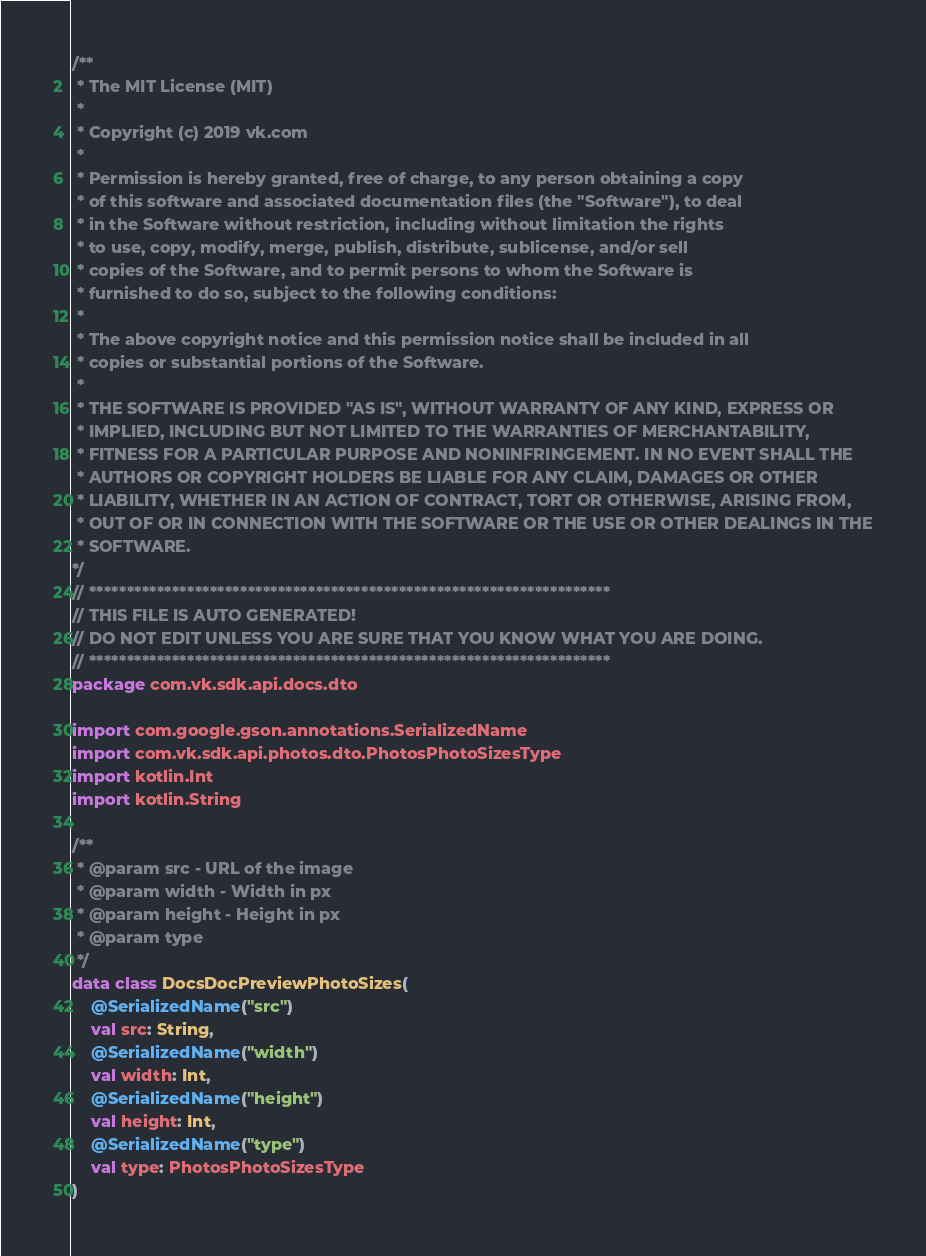Convert code to text. <code><loc_0><loc_0><loc_500><loc_500><_Kotlin_>/**
 * The MIT License (MIT)
 *
 * Copyright (c) 2019 vk.com
 *
 * Permission is hereby granted, free of charge, to any person obtaining a copy
 * of this software and associated documentation files (the "Software"), to deal
 * in the Software without restriction, including without limitation the rights
 * to use, copy, modify, merge, publish, distribute, sublicense, and/or sell
 * copies of the Software, and to permit persons to whom the Software is
 * furnished to do so, subject to the following conditions:
 *
 * The above copyright notice and this permission notice shall be included in all
 * copies or substantial portions of the Software.
 *
 * THE SOFTWARE IS PROVIDED "AS IS", WITHOUT WARRANTY OF ANY KIND, EXPRESS OR
 * IMPLIED, INCLUDING BUT NOT LIMITED TO THE WARRANTIES OF MERCHANTABILITY,
 * FITNESS FOR A PARTICULAR PURPOSE AND NONINFRINGEMENT. IN NO EVENT SHALL THE
 * AUTHORS OR COPYRIGHT HOLDERS BE LIABLE FOR ANY CLAIM, DAMAGES OR OTHER
 * LIABILITY, WHETHER IN AN ACTION OF CONTRACT, TORT OR OTHERWISE, ARISING FROM,
 * OUT OF OR IN CONNECTION WITH THE SOFTWARE OR THE USE OR OTHER DEALINGS IN THE
 * SOFTWARE.
*/
// *********************************************************************
// THIS FILE IS AUTO GENERATED!
// DO NOT EDIT UNLESS YOU ARE SURE THAT YOU KNOW WHAT YOU ARE DOING.
// *********************************************************************
package com.vk.sdk.api.docs.dto

import com.google.gson.annotations.SerializedName
import com.vk.sdk.api.photos.dto.PhotosPhotoSizesType
import kotlin.Int
import kotlin.String

/**
 * @param src - URL of the image
 * @param width - Width in px
 * @param height - Height in px
 * @param type
 */
data class DocsDocPreviewPhotoSizes(
    @SerializedName("src")
    val src: String,
    @SerializedName("width")
    val width: Int,
    @SerializedName("height")
    val height: Int,
    @SerializedName("type")
    val type: PhotosPhotoSizesType
)
</code> 